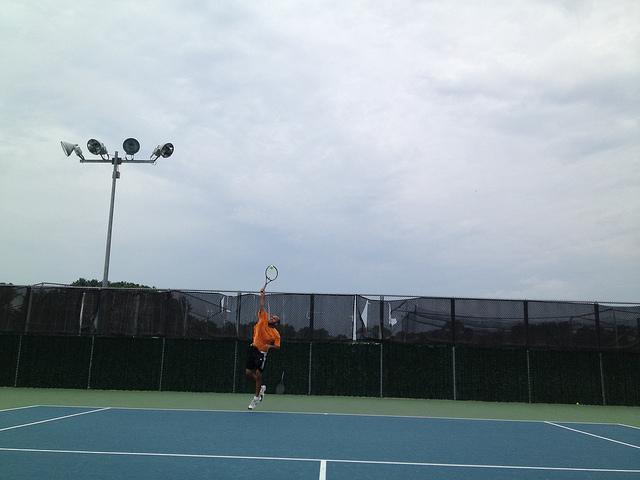How many lights are there?
Give a very brief answer. 4. 